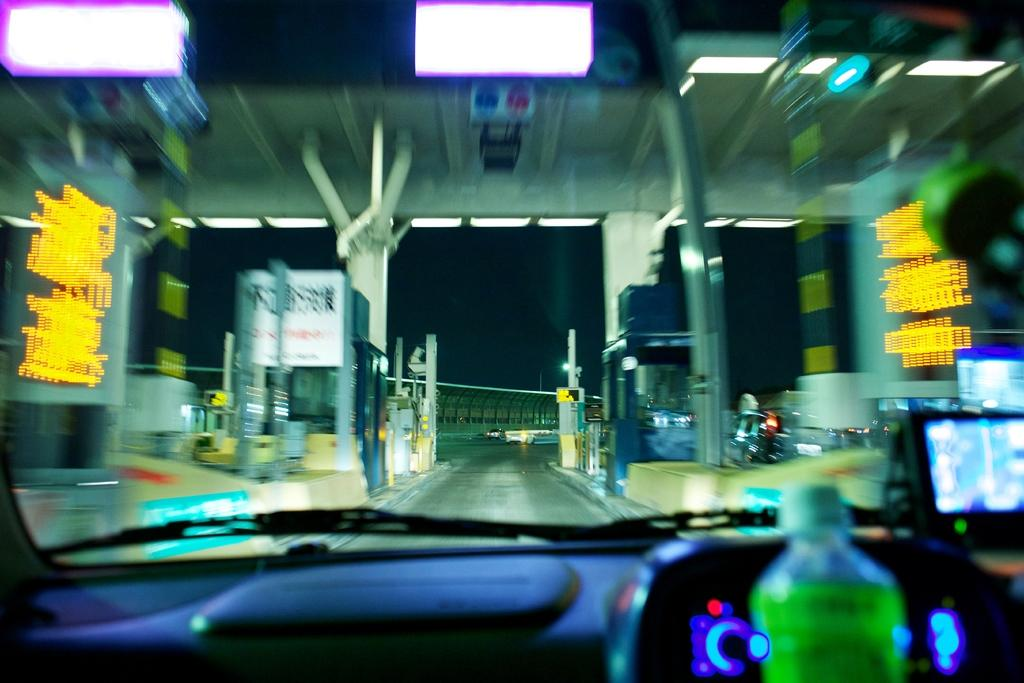What is the main subject of the image? The main subject of the image is a car. What feature of the car is visible in the image? The car has a wiper and a windshield. What can be seen through the windshield of the car? A flyover is visible through the windshield. How many pillars are present in the image? There are two pillars in the image. What structure is visible in the image? There is a gate in the image. What is visible in the background of the image? A road is visible in the background of the image. What type of paste can be seen on the windshield of the car in the image? There is no paste visible on the windshield of the car in the image. What type of bag is hanging from the gate in the image? There is no bag hanging from the gate in the image. 